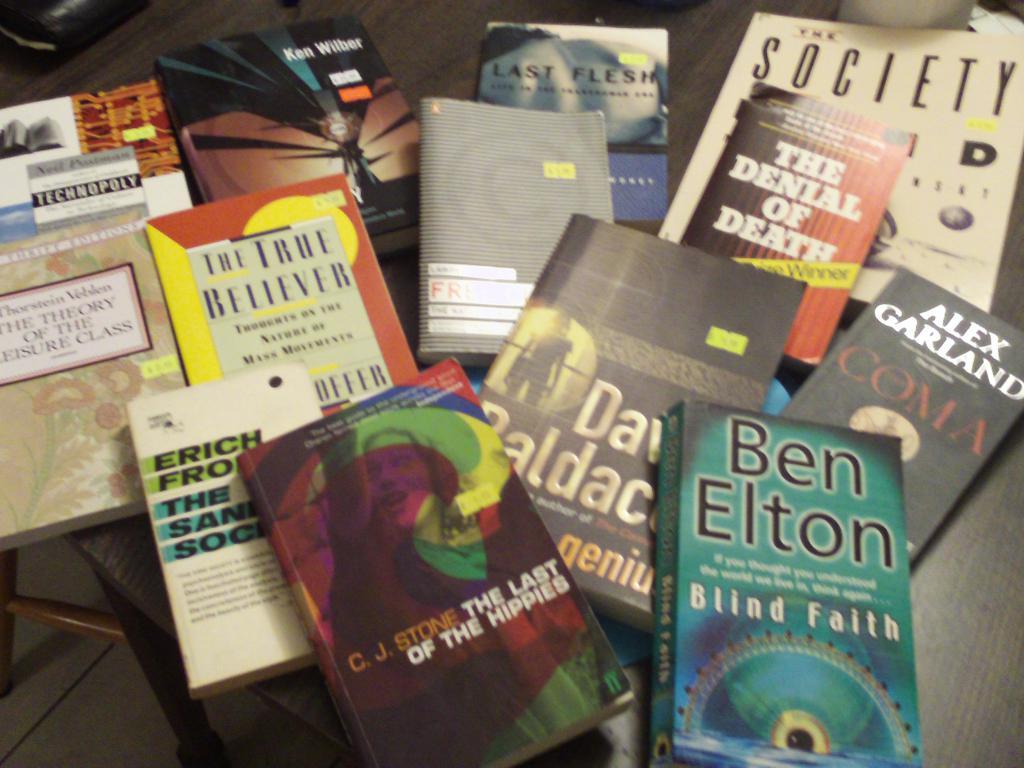Which book is by ben elton?
Offer a very short reply. Blind faith. Who wrote the book coma?
Your answer should be compact. Alex garland. 